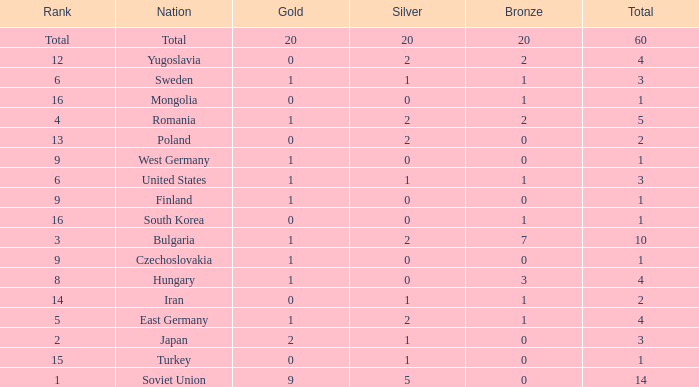What is the average silver for golds over 2, ranks of 1, and bronzes over 0? None. 